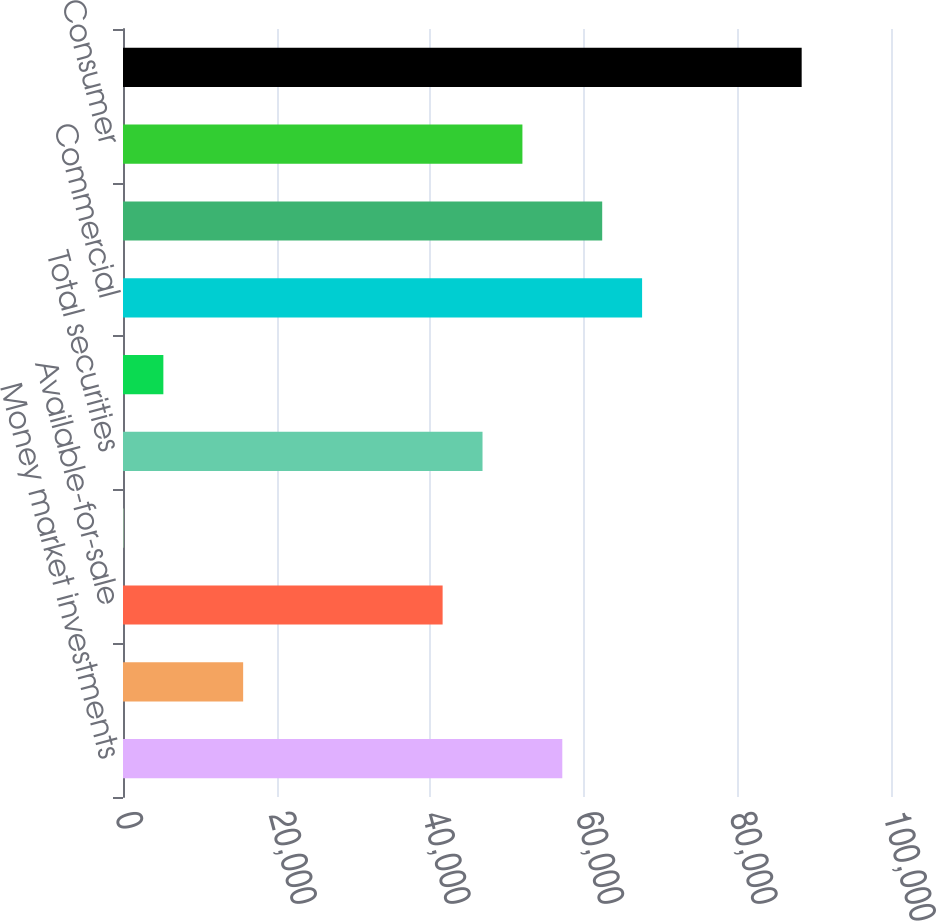Convert chart to OTSL. <chart><loc_0><loc_0><loc_500><loc_500><bar_chart><fcel>Money market investments<fcel>Held-to-maturity<fcel>Available-for-sale<fcel>Trading account<fcel>Total securities<fcel>Loans held for sale<fcel>Commercial<fcel>Commercial Real Estate<fcel>Consumer<fcel>Total Loans and leases<nl><fcel>57201.6<fcel>15644.8<fcel>41617.8<fcel>61<fcel>46812.4<fcel>5255.6<fcel>67590.8<fcel>62396.2<fcel>52007<fcel>88369.2<nl></chart> 